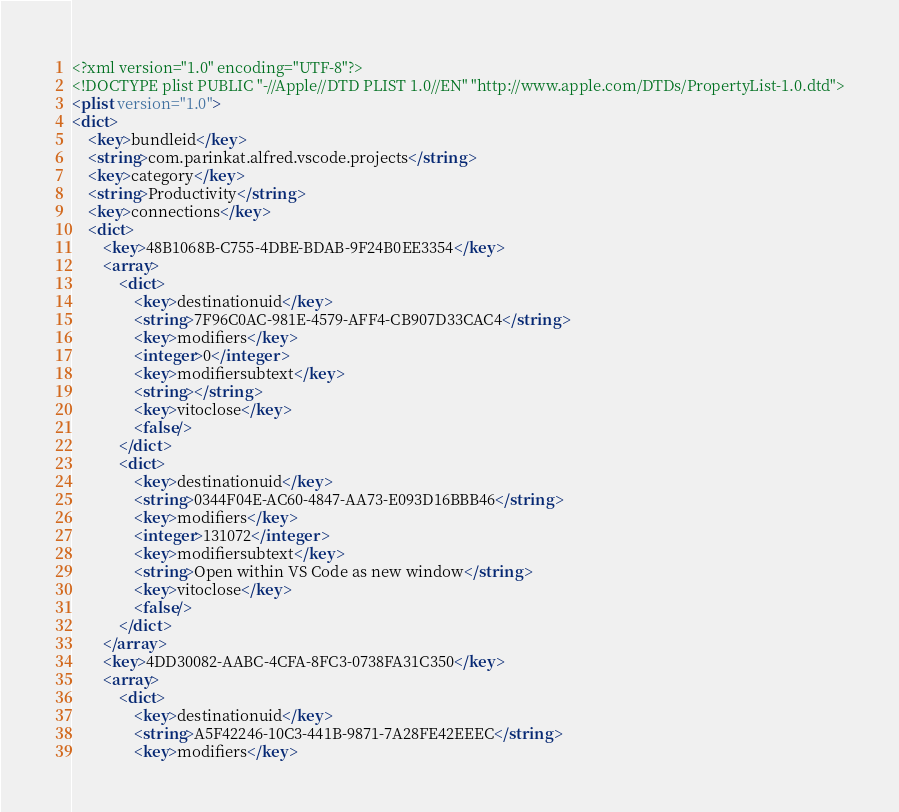<code> <loc_0><loc_0><loc_500><loc_500><_XML_><?xml version="1.0" encoding="UTF-8"?>
<!DOCTYPE plist PUBLIC "-//Apple//DTD PLIST 1.0//EN" "http://www.apple.com/DTDs/PropertyList-1.0.dtd">
<plist version="1.0">
<dict>
	<key>bundleid</key>
	<string>com.parinkat.alfred.vscode.projects</string>
	<key>category</key>
	<string>Productivity</string>
	<key>connections</key>
	<dict>
		<key>48B1068B-C755-4DBE-BDAB-9F24B0EE3354</key>
		<array>
			<dict>
				<key>destinationuid</key>
				<string>7F96C0AC-981E-4579-AFF4-CB907D33CAC4</string>
				<key>modifiers</key>
				<integer>0</integer>
				<key>modifiersubtext</key>
				<string></string>
				<key>vitoclose</key>
				<false/>
			</dict>
			<dict>
				<key>destinationuid</key>
				<string>0344F04E-AC60-4847-AA73-E093D16BBB46</string>
				<key>modifiers</key>
				<integer>131072</integer>
				<key>modifiersubtext</key>
				<string>Open within VS Code as new window</string>
				<key>vitoclose</key>
				<false/>
			</dict>
		</array>
		<key>4DD30082-AABC-4CFA-8FC3-0738FA31C350</key>
		<array>
			<dict>
				<key>destinationuid</key>
				<string>A5F42246-10C3-441B-9871-7A28FE42EEEC</string>
				<key>modifiers</key></code> 